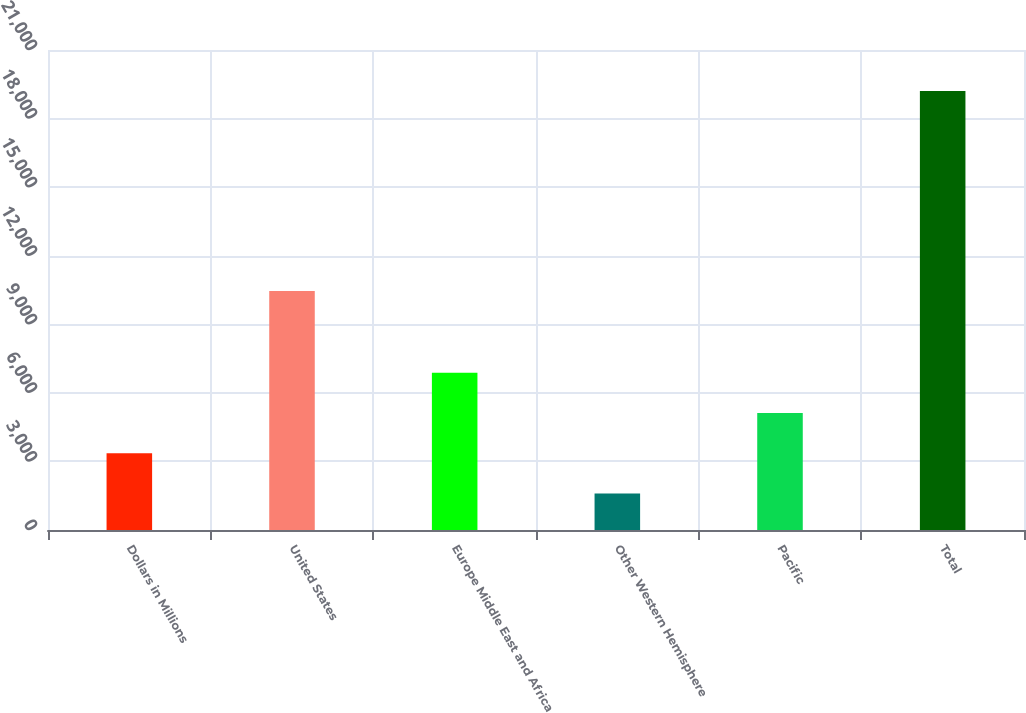Convert chart. <chart><loc_0><loc_0><loc_500><loc_500><bar_chart><fcel>Dollars in Millions<fcel>United States<fcel>Europe Middle East and Africa<fcel>Other Western Hemisphere<fcel>Pacific<fcel>Total<nl><fcel>3353.5<fcel>10461<fcel>6876.5<fcel>1592<fcel>5115<fcel>19207<nl></chart> 